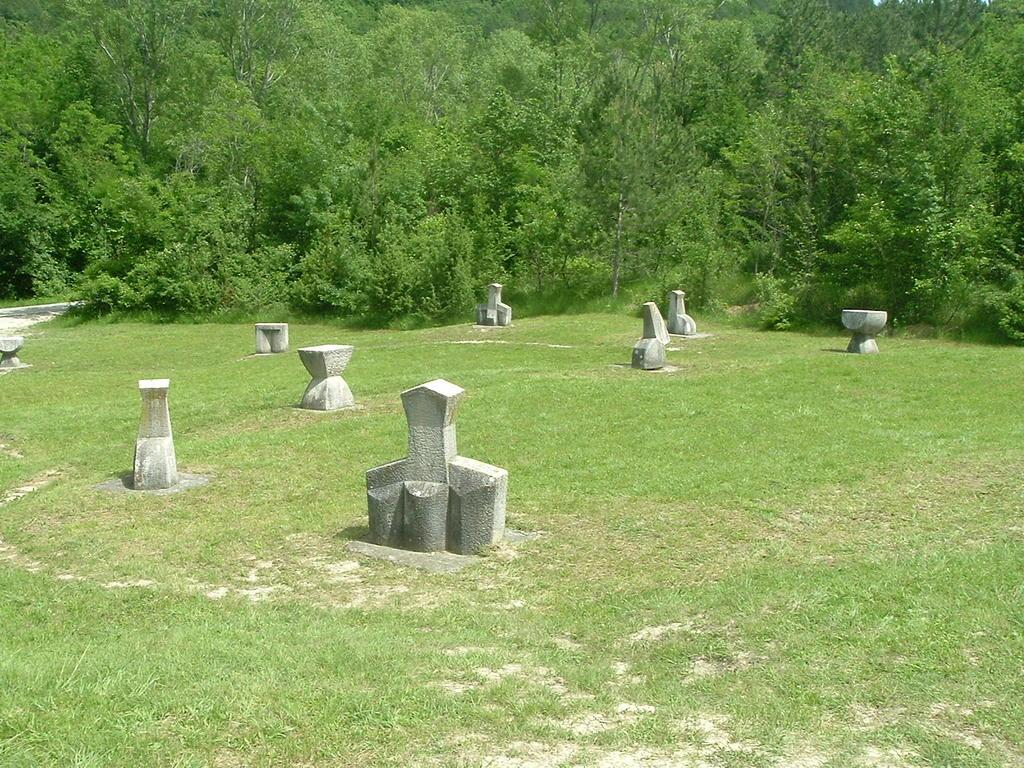What type of location is depicted in the image? The image contains cemeteries. What type of vegetation is present at the bottom of the image? There is grass at the bottom of the image. What can be seen in the background of the image? There are trees in the background of the image. What type of guitar is being played by the beggar in the image? There is no guitar or beggar present in the image. 